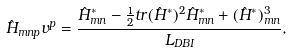Convert formula to latex. <formula><loc_0><loc_0><loc_500><loc_500>\hat { H } _ { m n p } v ^ { p } = { \frac { \hat { H } _ { m n } ^ { * } - { \frac { 1 } { 2 } } t r ( \hat { H } ^ { * } ) ^ { 2 } \hat { H } _ { m n } ^ { * } + ( \hat { H } ^ { * } ) _ { m n } ^ { 3 } } { L _ { D B I } } } ,</formula> 